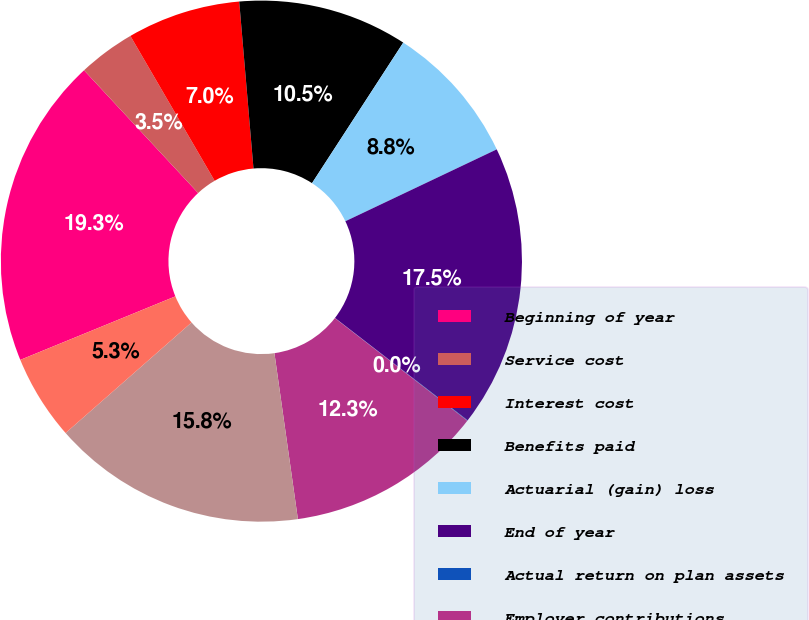Convert chart. <chart><loc_0><loc_0><loc_500><loc_500><pie_chart><fcel>Beginning of year<fcel>Service cost<fcel>Interest cost<fcel>Benefits paid<fcel>Actuarial (gain) loss<fcel>End of year<fcel>Actual return on plan assets<fcel>Employer contributions<fcel>Funded status and accrued<fcel>Current liabilities<nl><fcel>19.27%<fcel>3.53%<fcel>7.03%<fcel>10.52%<fcel>8.78%<fcel>17.52%<fcel>0.03%<fcel>12.27%<fcel>15.77%<fcel>5.28%<nl></chart> 